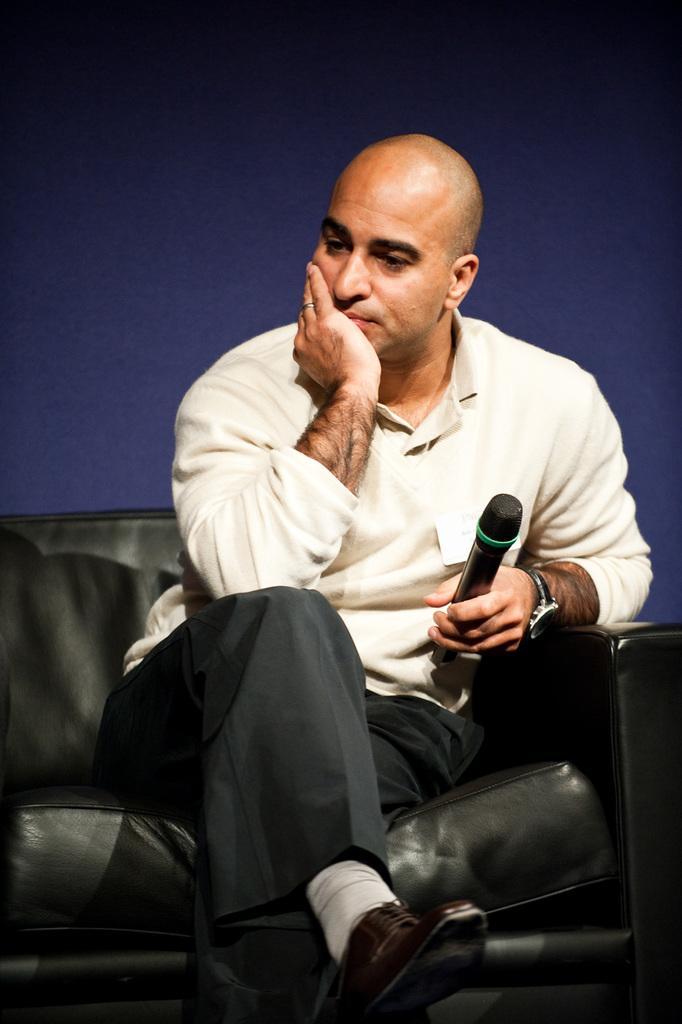Could you give a brief overview of what you see in this image? There is a man sitting on chair and holding a microphone,behind this man it is blue color. 